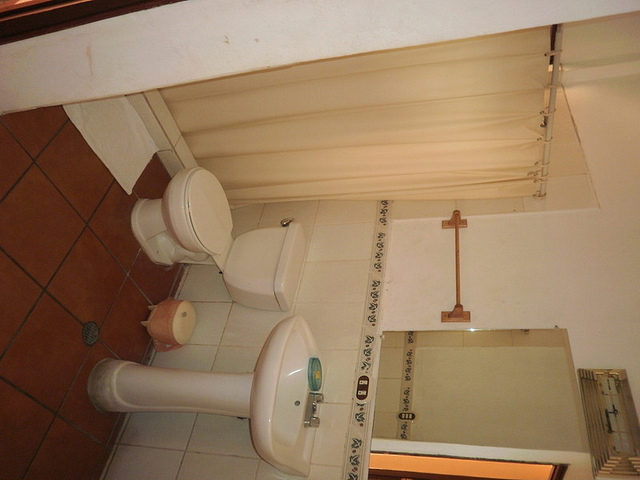<image>What angle is this shot presented at? It is ambiguous what angle this shot is presented at. It can be 'sideways', 'vertical' or at a 'right angle'. What angle is this shot presented at? I don't know at what angle this shot is presented. It can be seen at different angles such as 45 degrees, right angle, horizontal, sideways, vertical, surface view, or side. 